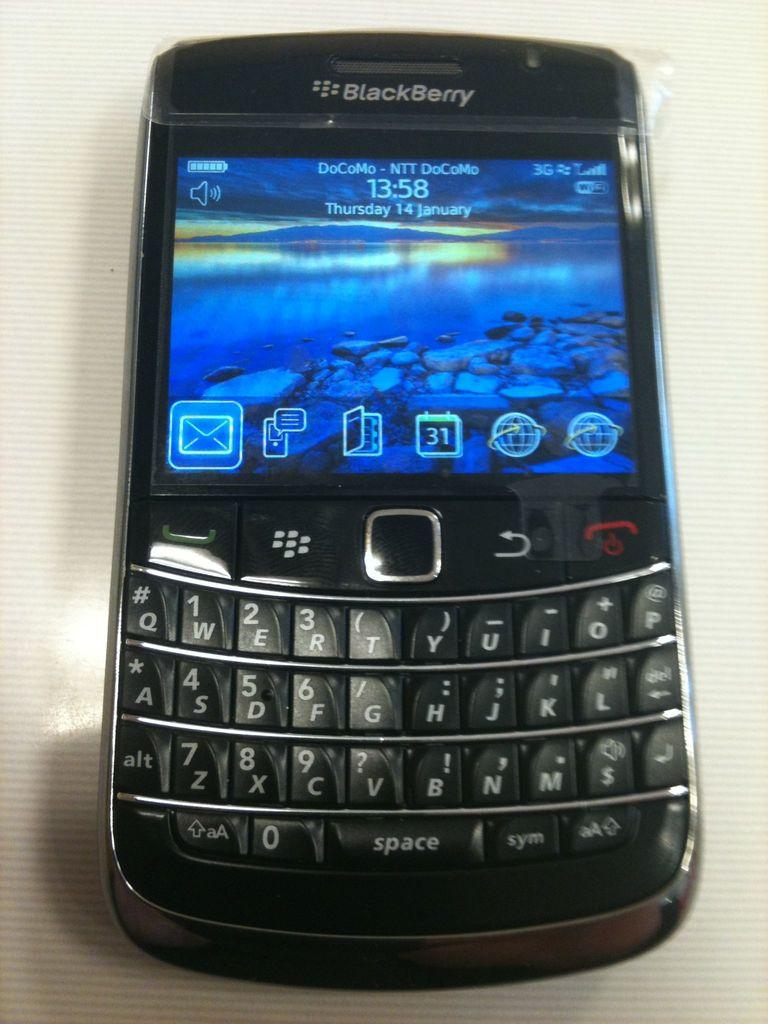<image>
Render a clear and concise summary of the photo. The screen of a BlackBerry shows the time to be 13:58 on Thursday 14 January. 